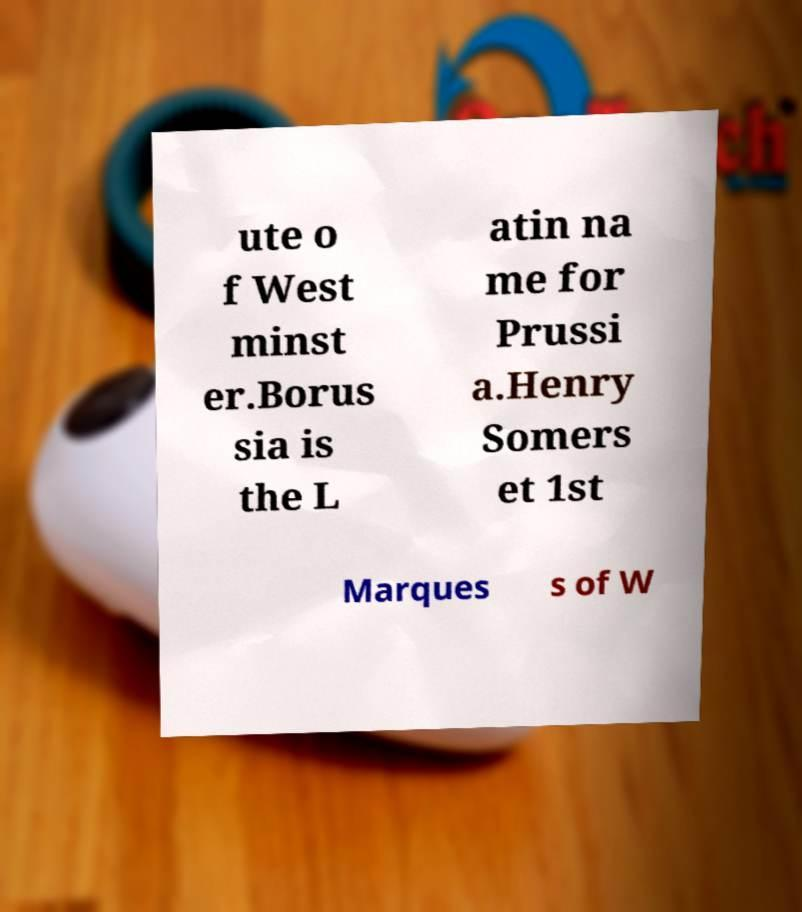Could you assist in decoding the text presented in this image and type it out clearly? ute o f West minst er.Borus sia is the L atin na me for Prussi a.Henry Somers et 1st Marques s of W 